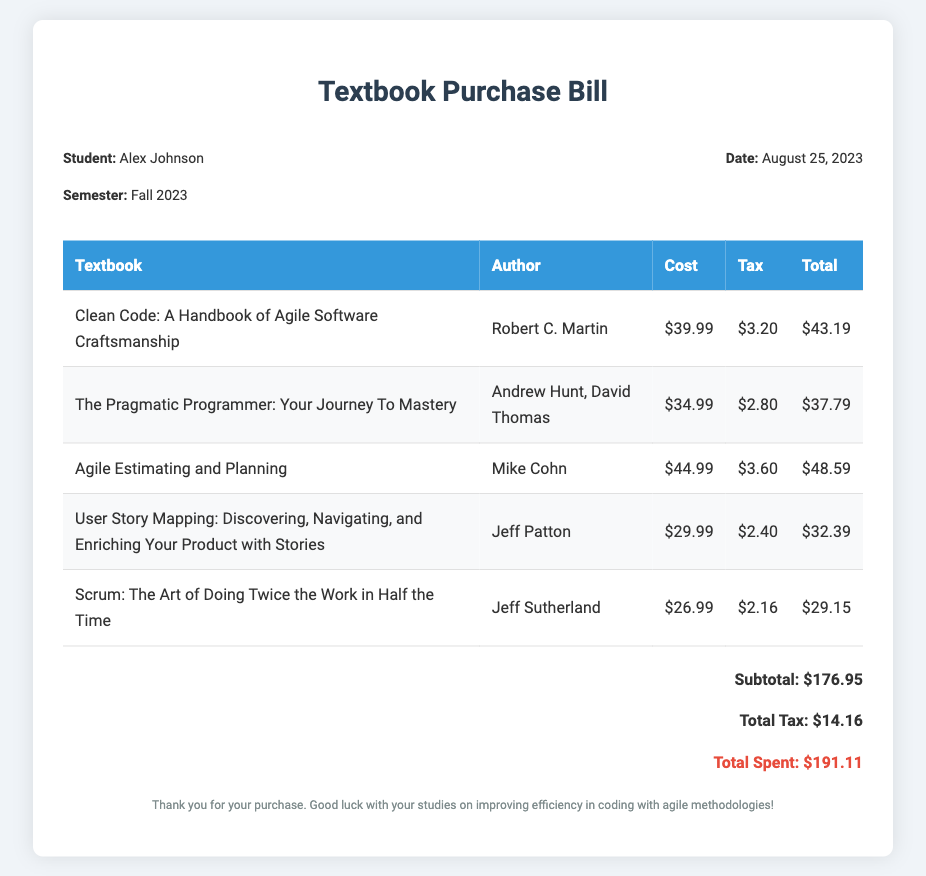What is the name of the student? The document mentions the student's name, which is Alex Johnson.
Answer: Alex Johnson What is the date of the bill? The date listed in the document is when the bill was created, which is August 25, 2023.
Answer: August 25, 2023 How many textbooks are listed in the bill? By counting the entries in the table, there are five textbooks listed.
Answer: 5 What is the total tax amount? The document summarizes the tax amounts for all textbooks, totaling $14.16.
Answer: $14.16 Who is the author of "Clean Code"? The document clearly states that Robert C. Martin is the author of "Clean Code".
Answer: Robert C. Martin What is the total spent for the semester? The final total listed in the document is the overall cost, which is $191.11.
Answer: $191.11 Which textbook has the highest cost? By comparing the costs of all textbooks, "Agile Estimating and Planning" cost $44.99, which is the highest.
Answer: Agile Estimating and Planning What is the subtotal of the books before tax? The subtotal before tax, as mentioned in the document, is $176.95.
Answer: $176.95 What is the title of the second textbook listed? The title of the second textbook in the table is "The Pragmatic Programmer: Your Journey To Mastery".
Answer: The Pragmatic Programmer: Your Journey To Mastery 